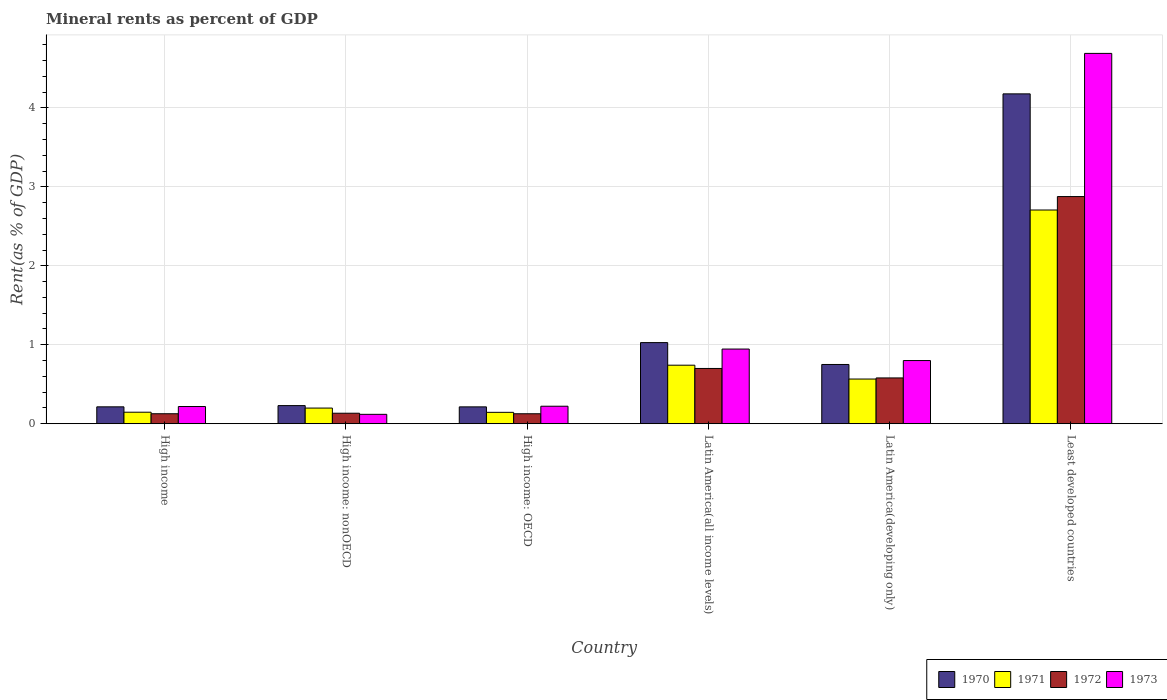How many groups of bars are there?
Your answer should be compact. 6. How many bars are there on the 2nd tick from the left?
Provide a short and direct response. 4. How many bars are there on the 2nd tick from the right?
Provide a succinct answer. 4. What is the label of the 5th group of bars from the left?
Offer a terse response. Latin America(developing only). In how many cases, is the number of bars for a given country not equal to the number of legend labels?
Your response must be concise. 0. What is the mineral rent in 1970 in High income: OECD?
Ensure brevity in your answer.  0.21. Across all countries, what is the maximum mineral rent in 1971?
Your answer should be compact. 2.71. Across all countries, what is the minimum mineral rent in 1971?
Ensure brevity in your answer.  0.14. In which country was the mineral rent in 1971 maximum?
Provide a succinct answer. Least developed countries. In which country was the mineral rent in 1972 minimum?
Your response must be concise. High income: OECD. What is the total mineral rent in 1972 in the graph?
Keep it short and to the point. 4.54. What is the difference between the mineral rent in 1971 in High income: OECD and that in Least developed countries?
Ensure brevity in your answer.  -2.56. What is the difference between the mineral rent in 1971 in High income: nonOECD and the mineral rent in 1973 in Latin America(all income levels)?
Your answer should be compact. -0.75. What is the average mineral rent in 1970 per country?
Your answer should be compact. 1.1. What is the difference between the mineral rent of/in 1972 and mineral rent of/in 1971 in High income: OECD?
Your answer should be compact. -0.02. What is the ratio of the mineral rent in 1973 in High income: OECD to that in High income: nonOECD?
Make the answer very short. 1.86. Is the mineral rent in 1972 in High income: nonOECD less than that in Latin America(all income levels)?
Keep it short and to the point. Yes. What is the difference between the highest and the second highest mineral rent in 1970?
Keep it short and to the point. -0.28. What is the difference between the highest and the lowest mineral rent in 1973?
Give a very brief answer. 4.57. Is the sum of the mineral rent in 1972 in High income: nonOECD and Latin America(all income levels) greater than the maximum mineral rent in 1971 across all countries?
Offer a very short reply. No. Is it the case that in every country, the sum of the mineral rent in 1970 and mineral rent in 1973 is greater than the sum of mineral rent in 1972 and mineral rent in 1971?
Your response must be concise. No. What does the 1st bar from the left in High income represents?
Your answer should be very brief. 1970. What does the 3rd bar from the right in Least developed countries represents?
Make the answer very short. 1971. How many bars are there?
Make the answer very short. 24. Does the graph contain any zero values?
Provide a succinct answer. No. Does the graph contain grids?
Provide a succinct answer. Yes. How many legend labels are there?
Make the answer very short. 4. How are the legend labels stacked?
Provide a succinct answer. Horizontal. What is the title of the graph?
Provide a succinct answer. Mineral rents as percent of GDP. What is the label or title of the Y-axis?
Keep it short and to the point. Rent(as % of GDP). What is the Rent(as % of GDP) in 1970 in High income?
Provide a succinct answer. 0.21. What is the Rent(as % of GDP) in 1971 in High income?
Offer a terse response. 0.15. What is the Rent(as % of GDP) of 1972 in High income?
Your answer should be compact. 0.13. What is the Rent(as % of GDP) in 1973 in High income?
Ensure brevity in your answer.  0.22. What is the Rent(as % of GDP) in 1970 in High income: nonOECD?
Offer a terse response. 0.23. What is the Rent(as % of GDP) in 1971 in High income: nonOECD?
Give a very brief answer. 0.2. What is the Rent(as % of GDP) of 1972 in High income: nonOECD?
Ensure brevity in your answer.  0.13. What is the Rent(as % of GDP) in 1973 in High income: nonOECD?
Provide a succinct answer. 0.12. What is the Rent(as % of GDP) in 1970 in High income: OECD?
Offer a very short reply. 0.21. What is the Rent(as % of GDP) of 1971 in High income: OECD?
Offer a very short reply. 0.14. What is the Rent(as % of GDP) in 1972 in High income: OECD?
Make the answer very short. 0.13. What is the Rent(as % of GDP) in 1973 in High income: OECD?
Your answer should be compact. 0.22. What is the Rent(as % of GDP) in 1970 in Latin America(all income levels)?
Offer a very short reply. 1.03. What is the Rent(as % of GDP) of 1971 in Latin America(all income levels)?
Offer a very short reply. 0.74. What is the Rent(as % of GDP) in 1972 in Latin America(all income levels)?
Your answer should be very brief. 0.7. What is the Rent(as % of GDP) in 1973 in Latin America(all income levels)?
Ensure brevity in your answer.  0.95. What is the Rent(as % of GDP) in 1970 in Latin America(developing only)?
Offer a terse response. 0.75. What is the Rent(as % of GDP) in 1971 in Latin America(developing only)?
Keep it short and to the point. 0.57. What is the Rent(as % of GDP) in 1972 in Latin America(developing only)?
Provide a short and direct response. 0.58. What is the Rent(as % of GDP) in 1973 in Latin America(developing only)?
Give a very brief answer. 0.8. What is the Rent(as % of GDP) of 1970 in Least developed countries?
Your response must be concise. 4.18. What is the Rent(as % of GDP) in 1971 in Least developed countries?
Your response must be concise. 2.71. What is the Rent(as % of GDP) of 1972 in Least developed countries?
Provide a succinct answer. 2.88. What is the Rent(as % of GDP) of 1973 in Least developed countries?
Keep it short and to the point. 4.69. Across all countries, what is the maximum Rent(as % of GDP) in 1970?
Make the answer very short. 4.18. Across all countries, what is the maximum Rent(as % of GDP) of 1971?
Offer a terse response. 2.71. Across all countries, what is the maximum Rent(as % of GDP) in 1972?
Provide a short and direct response. 2.88. Across all countries, what is the maximum Rent(as % of GDP) of 1973?
Provide a short and direct response. 4.69. Across all countries, what is the minimum Rent(as % of GDP) of 1970?
Offer a very short reply. 0.21. Across all countries, what is the minimum Rent(as % of GDP) of 1971?
Your answer should be very brief. 0.14. Across all countries, what is the minimum Rent(as % of GDP) in 1972?
Your answer should be very brief. 0.13. Across all countries, what is the minimum Rent(as % of GDP) in 1973?
Offer a terse response. 0.12. What is the total Rent(as % of GDP) of 1970 in the graph?
Offer a very short reply. 6.61. What is the total Rent(as % of GDP) of 1971 in the graph?
Your response must be concise. 4.5. What is the total Rent(as % of GDP) of 1972 in the graph?
Keep it short and to the point. 4.54. What is the total Rent(as % of GDP) of 1973 in the graph?
Offer a terse response. 6.99. What is the difference between the Rent(as % of GDP) in 1970 in High income and that in High income: nonOECD?
Offer a terse response. -0.02. What is the difference between the Rent(as % of GDP) of 1971 in High income and that in High income: nonOECD?
Provide a short and direct response. -0.05. What is the difference between the Rent(as % of GDP) of 1972 in High income and that in High income: nonOECD?
Give a very brief answer. -0.01. What is the difference between the Rent(as % of GDP) of 1973 in High income and that in High income: nonOECD?
Give a very brief answer. 0.1. What is the difference between the Rent(as % of GDP) of 1970 in High income and that in High income: OECD?
Your response must be concise. 0. What is the difference between the Rent(as % of GDP) in 1971 in High income and that in High income: OECD?
Ensure brevity in your answer.  0. What is the difference between the Rent(as % of GDP) of 1972 in High income and that in High income: OECD?
Ensure brevity in your answer.  0. What is the difference between the Rent(as % of GDP) in 1973 in High income and that in High income: OECD?
Give a very brief answer. -0. What is the difference between the Rent(as % of GDP) of 1970 in High income and that in Latin America(all income levels)?
Make the answer very short. -0.81. What is the difference between the Rent(as % of GDP) of 1971 in High income and that in Latin America(all income levels)?
Your response must be concise. -0.6. What is the difference between the Rent(as % of GDP) of 1972 in High income and that in Latin America(all income levels)?
Provide a short and direct response. -0.57. What is the difference between the Rent(as % of GDP) of 1973 in High income and that in Latin America(all income levels)?
Your response must be concise. -0.73. What is the difference between the Rent(as % of GDP) in 1970 in High income and that in Latin America(developing only)?
Offer a terse response. -0.54. What is the difference between the Rent(as % of GDP) in 1971 in High income and that in Latin America(developing only)?
Offer a terse response. -0.42. What is the difference between the Rent(as % of GDP) in 1972 in High income and that in Latin America(developing only)?
Your answer should be compact. -0.45. What is the difference between the Rent(as % of GDP) in 1973 in High income and that in Latin America(developing only)?
Your answer should be very brief. -0.58. What is the difference between the Rent(as % of GDP) of 1970 in High income and that in Least developed countries?
Your answer should be very brief. -3.96. What is the difference between the Rent(as % of GDP) in 1971 in High income and that in Least developed countries?
Offer a terse response. -2.56. What is the difference between the Rent(as % of GDP) in 1972 in High income and that in Least developed countries?
Ensure brevity in your answer.  -2.75. What is the difference between the Rent(as % of GDP) in 1973 in High income and that in Least developed countries?
Provide a succinct answer. -4.47. What is the difference between the Rent(as % of GDP) in 1970 in High income: nonOECD and that in High income: OECD?
Give a very brief answer. 0.02. What is the difference between the Rent(as % of GDP) in 1971 in High income: nonOECD and that in High income: OECD?
Provide a succinct answer. 0.05. What is the difference between the Rent(as % of GDP) of 1972 in High income: nonOECD and that in High income: OECD?
Offer a very short reply. 0.01. What is the difference between the Rent(as % of GDP) in 1973 in High income: nonOECD and that in High income: OECD?
Provide a succinct answer. -0.1. What is the difference between the Rent(as % of GDP) of 1970 in High income: nonOECD and that in Latin America(all income levels)?
Ensure brevity in your answer.  -0.8. What is the difference between the Rent(as % of GDP) in 1971 in High income: nonOECD and that in Latin America(all income levels)?
Provide a succinct answer. -0.54. What is the difference between the Rent(as % of GDP) in 1972 in High income: nonOECD and that in Latin America(all income levels)?
Provide a short and direct response. -0.57. What is the difference between the Rent(as % of GDP) of 1973 in High income: nonOECD and that in Latin America(all income levels)?
Offer a very short reply. -0.83. What is the difference between the Rent(as % of GDP) of 1970 in High income: nonOECD and that in Latin America(developing only)?
Provide a succinct answer. -0.52. What is the difference between the Rent(as % of GDP) of 1971 in High income: nonOECD and that in Latin America(developing only)?
Keep it short and to the point. -0.37. What is the difference between the Rent(as % of GDP) of 1972 in High income: nonOECD and that in Latin America(developing only)?
Your answer should be very brief. -0.45. What is the difference between the Rent(as % of GDP) of 1973 in High income: nonOECD and that in Latin America(developing only)?
Your response must be concise. -0.68. What is the difference between the Rent(as % of GDP) in 1970 in High income: nonOECD and that in Least developed countries?
Your answer should be compact. -3.95. What is the difference between the Rent(as % of GDP) in 1971 in High income: nonOECD and that in Least developed countries?
Your answer should be compact. -2.51. What is the difference between the Rent(as % of GDP) of 1972 in High income: nonOECD and that in Least developed countries?
Keep it short and to the point. -2.74. What is the difference between the Rent(as % of GDP) in 1973 in High income: nonOECD and that in Least developed countries?
Provide a short and direct response. -4.57. What is the difference between the Rent(as % of GDP) in 1970 in High income: OECD and that in Latin America(all income levels)?
Provide a succinct answer. -0.81. What is the difference between the Rent(as % of GDP) in 1971 in High income: OECD and that in Latin America(all income levels)?
Offer a terse response. -0.6. What is the difference between the Rent(as % of GDP) in 1972 in High income: OECD and that in Latin America(all income levels)?
Your answer should be compact. -0.57. What is the difference between the Rent(as % of GDP) of 1973 in High income: OECD and that in Latin America(all income levels)?
Your answer should be compact. -0.72. What is the difference between the Rent(as % of GDP) of 1970 in High income: OECD and that in Latin America(developing only)?
Your response must be concise. -0.54. What is the difference between the Rent(as % of GDP) in 1971 in High income: OECD and that in Latin America(developing only)?
Make the answer very short. -0.42. What is the difference between the Rent(as % of GDP) in 1972 in High income: OECD and that in Latin America(developing only)?
Make the answer very short. -0.45. What is the difference between the Rent(as % of GDP) of 1973 in High income: OECD and that in Latin America(developing only)?
Provide a succinct answer. -0.58. What is the difference between the Rent(as % of GDP) in 1970 in High income: OECD and that in Least developed countries?
Give a very brief answer. -3.96. What is the difference between the Rent(as % of GDP) of 1971 in High income: OECD and that in Least developed countries?
Your answer should be compact. -2.56. What is the difference between the Rent(as % of GDP) in 1972 in High income: OECD and that in Least developed countries?
Your response must be concise. -2.75. What is the difference between the Rent(as % of GDP) of 1973 in High income: OECD and that in Least developed countries?
Offer a very short reply. -4.47. What is the difference between the Rent(as % of GDP) in 1970 in Latin America(all income levels) and that in Latin America(developing only)?
Provide a short and direct response. 0.28. What is the difference between the Rent(as % of GDP) of 1971 in Latin America(all income levels) and that in Latin America(developing only)?
Your response must be concise. 0.18. What is the difference between the Rent(as % of GDP) of 1972 in Latin America(all income levels) and that in Latin America(developing only)?
Your answer should be compact. 0.12. What is the difference between the Rent(as % of GDP) of 1973 in Latin America(all income levels) and that in Latin America(developing only)?
Give a very brief answer. 0.15. What is the difference between the Rent(as % of GDP) of 1970 in Latin America(all income levels) and that in Least developed countries?
Provide a short and direct response. -3.15. What is the difference between the Rent(as % of GDP) of 1971 in Latin America(all income levels) and that in Least developed countries?
Ensure brevity in your answer.  -1.97. What is the difference between the Rent(as % of GDP) in 1972 in Latin America(all income levels) and that in Least developed countries?
Ensure brevity in your answer.  -2.18. What is the difference between the Rent(as % of GDP) of 1973 in Latin America(all income levels) and that in Least developed countries?
Offer a very short reply. -3.74. What is the difference between the Rent(as % of GDP) of 1970 in Latin America(developing only) and that in Least developed countries?
Your answer should be compact. -3.43. What is the difference between the Rent(as % of GDP) in 1971 in Latin America(developing only) and that in Least developed countries?
Your response must be concise. -2.14. What is the difference between the Rent(as % of GDP) in 1972 in Latin America(developing only) and that in Least developed countries?
Your response must be concise. -2.3. What is the difference between the Rent(as % of GDP) of 1973 in Latin America(developing only) and that in Least developed countries?
Give a very brief answer. -3.89. What is the difference between the Rent(as % of GDP) in 1970 in High income and the Rent(as % of GDP) in 1971 in High income: nonOECD?
Keep it short and to the point. 0.02. What is the difference between the Rent(as % of GDP) in 1970 in High income and the Rent(as % of GDP) in 1972 in High income: nonOECD?
Offer a terse response. 0.08. What is the difference between the Rent(as % of GDP) in 1970 in High income and the Rent(as % of GDP) in 1973 in High income: nonOECD?
Provide a short and direct response. 0.1. What is the difference between the Rent(as % of GDP) of 1971 in High income and the Rent(as % of GDP) of 1972 in High income: nonOECD?
Ensure brevity in your answer.  0.01. What is the difference between the Rent(as % of GDP) of 1971 in High income and the Rent(as % of GDP) of 1973 in High income: nonOECD?
Offer a very short reply. 0.03. What is the difference between the Rent(as % of GDP) of 1972 in High income and the Rent(as % of GDP) of 1973 in High income: nonOECD?
Your answer should be very brief. 0.01. What is the difference between the Rent(as % of GDP) of 1970 in High income and the Rent(as % of GDP) of 1971 in High income: OECD?
Give a very brief answer. 0.07. What is the difference between the Rent(as % of GDP) of 1970 in High income and the Rent(as % of GDP) of 1972 in High income: OECD?
Offer a terse response. 0.09. What is the difference between the Rent(as % of GDP) of 1970 in High income and the Rent(as % of GDP) of 1973 in High income: OECD?
Offer a very short reply. -0.01. What is the difference between the Rent(as % of GDP) in 1971 in High income and the Rent(as % of GDP) in 1972 in High income: OECD?
Keep it short and to the point. 0.02. What is the difference between the Rent(as % of GDP) in 1971 in High income and the Rent(as % of GDP) in 1973 in High income: OECD?
Provide a short and direct response. -0.08. What is the difference between the Rent(as % of GDP) of 1972 in High income and the Rent(as % of GDP) of 1973 in High income: OECD?
Your response must be concise. -0.1. What is the difference between the Rent(as % of GDP) in 1970 in High income and the Rent(as % of GDP) in 1971 in Latin America(all income levels)?
Offer a very short reply. -0.53. What is the difference between the Rent(as % of GDP) in 1970 in High income and the Rent(as % of GDP) in 1972 in Latin America(all income levels)?
Your answer should be compact. -0.49. What is the difference between the Rent(as % of GDP) in 1970 in High income and the Rent(as % of GDP) in 1973 in Latin America(all income levels)?
Provide a succinct answer. -0.73. What is the difference between the Rent(as % of GDP) of 1971 in High income and the Rent(as % of GDP) of 1972 in Latin America(all income levels)?
Ensure brevity in your answer.  -0.55. What is the difference between the Rent(as % of GDP) of 1971 in High income and the Rent(as % of GDP) of 1973 in Latin America(all income levels)?
Keep it short and to the point. -0.8. What is the difference between the Rent(as % of GDP) of 1972 in High income and the Rent(as % of GDP) of 1973 in Latin America(all income levels)?
Provide a short and direct response. -0.82. What is the difference between the Rent(as % of GDP) in 1970 in High income and the Rent(as % of GDP) in 1971 in Latin America(developing only)?
Your response must be concise. -0.35. What is the difference between the Rent(as % of GDP) of 1970 in High income and the Rent(as % of GDP) of 1972 in Latin America(developing only)?
Your answer should be very brief. -0.37. What is the difference between the Rent(as % of GDP) of 1970 in High income and the Rent(as % of GDP) of 1973 in Latin America(developing only)?
Offer a very short reply. -0.59. What is the difference between the Rent(as % of GDP) of 1971 in High income and the Rent(as % of GDP) of 1972 in Latin America(developing only)?
Your answer should be compact. -0.43. What is the difference between the Rent(as % of GDP) of 1971 in High income and the Rent(as % of GDP) of 1973 in Latin America(developing only)?
Provide a short and direct response. -0.65. What is the difference between the Rent(as % of GDP) in 1972 in High income and the Rent(as % of GDP) in 1973 in Latin America(developing only)?
Offer a terse response. -0.67. What is the difference between the Rent(as % of GDP) in 1970 in High income and the Rent(as % of GDP) in 1971 in Least developed countries?
Provide a short and direct response. -2.49. What is the difference between the Rent(as % of GDP) in 1970 in High income and the Rent(as % of GDP) in 1972 in Least developed countries?
Offer a very short reply. -2.66. What is the difference between the Rent(as % of GDP) in 1970 in High income and the Rent(as % of GDP) in 1973 in Least developed countries?
Ensure brevity in your answer.  -4.48. What is the difference between the Rent(as % of GDP) of 1971 in High income and the Rent(as % of GDP) of 1972 in Least developed countries?
Your response must be concise. -2.73. What is the difference between the Rent(as % of GDP) in 1971 in High income and the Rent(as % of GDP) in 1973 in Least developed countries?
Keep it short and to the point. -4.54. What is the difference between the Rent(as % of GDP) of 1972 in High income and the Rent(as % of GDP) of 1973 in Least developed countries?
Offer a terse response. -4.56. What is the difference between the Rent(as % of GDP) in 1970 in High income: nonOECD and the Rent(as % of GDP) in 1971 in High income: OECD?
Give a very brief answer. 0.09. What is the difference between the Rent(as % of GDP) of 1970 in High income: nonOECD and the Rent(as % of GDP) of 1972 in High income: OECD?
Offer a very short reply. 0.1. What is the difference between the Rent(as % of GDP) of 1970 in High income: nonOECD and the Rent(as % of GDP) of 1973 in High income: OECD?
Your answer should be compact. 0.01. What is the difference between the Rent(as % of GDP) of 1971 in High income: nonOECD and the Rent(as % of GDP) of 1972 in High income: OECD?
Provide a succinct answer. 0.07. What is the difference between the Rent(as % of GDP) of 1971 in High income: nonOECD and the Rent(as % of GDP) of 1973 in High income: OECD?
Provide a short and direct response. -0.02. What is the difference between the Rent(as % of GDP) in 1972 in High income: nonOECD and the Rent(as % of GDP) in 1973 in High income: OECD?
Ensure brevity in your answer.  -0.09. What is the difference between the Rent(as % of GDP) in 1970 in High income: nonOECD and the Rent(as % of GDP) in 1971 in Latin America(all income levels)?
Your answer should be very brief. -0.51. What is the difference between the Rent(as % of GDP) of 1970 in High income: nonOECD and the Rent(as % of GDP) of 1972 in Latin America(all income levels)?
Give a very brief answer. -0.47. What is the difference between the Rent(as % of GDP) of 1970 in High income: nonOECD and the Rent(as % of GDP) of 1973 in Latin America(all income levels)?
Your answer should be compact. -0.72. What is the difference between the Rent(as % of GDP) in 1971 in High income: nonOECD and the Rent(as % of GDP) in 1972 in Latin America(all income levels)?
Offer a terse response. -0.5. What is the difference between the Rent(as % of GDP) of 1971 in High income: nonOECD and the Rent(as % of GDP) of 1973 in Latin America(all income levels)?
Offer a very short reply. -0.75. What is the difference between the Rent(as % of GDP) of 1972 in High income: nonOECD and the Rent(as % of GDP) of 1973 in Latin America(all income levels)?
Make the answer very short. -0.81. What is the difference between the Rent(as % of GDP) of 1970 in High income: nonOECD and the Rent(as % of GDP) of 1971 in Latin America(developing only)?
Make the answer very short. -0.34. What is the difference between the Rent(as % of GDP) in 1970 in High income: nonOECD and the Rent(as % of GDP) in 1972 in Latin America(developing only)?
Ensure brevity in your answer.  -0.35. What is the difference between the Rent(as % of GDP) of 1970 in High income: nonOECD and the Rent(as % of GDP) of 1973 in Latin America(developing only)?
Offer a very short reply. -0.57. What is the difference between the Rent(as % of GDP) of 1971 in High income: nonOECD and the Rent(as % of GDP) of 1972 in Latin America(developing only)?
Give a very brief answer. -0.38. What is the difference between the Rent(as % of GDP) of 1971 in High income: nonOECD and the Rent(as % of GDP) of 1973 in Latin America(developing only)?
Your response must be concise. -0.6. What is the difference between the Rent(as % of GDP) of 1972 in High income: nonOECD and the Rent(as % of GDP) of 1973 in Latin America(developing only)?
Offer a very short reply. -0.67. What is the difference between the Rent(as % of GDP) in 1970 in High income: nonOECD and the Rent(as % of GDP) in 1971 in Least developed countries?
Your answer should be very brief. -2.48. What is the difference between the Rent(as % of GDP) in 1970 in High income: nonOECD and the Rent(as % of GDP) in 1972 in Least developed countries?
Your answer should be compact. -2.65. What is the difference between the Rent(as % of GDP) of 1970 in High income: nonOECD and the Rent(as % of GDP) of 1973 in Least developed countries?
Your response must be concise. -4.46. What is the difference between the Rent(as % of GDP) of 1971 in High income: nonOECD and the Rent(as % of GDP) of 1972 in Least developed countries?
Keep it short and to the point. -2.68. What is the difference between the Rent(as % of GDP) in 1971 in High income: nonOECD and the Rent(as % of GDP) in 1973 in Least developed countries?
Offer a very short reply. -4.49. What is the difference between the Rent(as % of GDP) of 1972 in High income: nonOECD and the Rent(as % of GDP) of 1973 in Least developed countries?
Your answer should be compact. -4.56. What is the difference between the Rent(as % of GDP) of 1970 in High income: OECD and the Rent(as % of GDP) of 1971 in Latin America(all income levels)?
Offer a very short reply. -0.53. What is the difference between the Rent(as % of GDP) in 1970 in High income: OECD and the Rent(as % of GDP) in 1972 in Latin America(all income levels)?
Provide a short and direct response. -0.49. What is the difference between the Rent(as % of GDP) of 1970 in High income: OECD and the Rent(as % of GDP) of 1973 in Latin America(all income levels)?
Your answer should be very brief. -0.73. What is the difference between the Rent(as % of GDP) in 1971 in High income: OECD and the Rent(as % of GDP) in 1972 in Latin America(all income levels)?
Your answer should be compact. -0.56. What is the difference between the Rent(as % of GDP) of 1971 in High income: OECD and the Rent(as % of GDP) of 1973 in Latin America(all income levels)?
Ensure brevity in your answer.  -0.8. What is the difference between the Rent(as % of GDP) of 1972 in High income: OECD and the Rent(as % of GDP) of 1973 in Latin America(all income levels)?
Your answer should be very brief. -0.82. What is the difference between the Rent(as % of GDP) in 1970 in High income: OECD and the Rent(as % of GDP) in 1971 in Latin America(developing only)?
Ensure brevity in your answer.  -0.35. What is the difference between the Rent(as % of GDP) of 1970 in High income: OECD and the Rent(as % of GDP) of 1972 in Latin America(developing only)?
Keep it short and to the point. -0.37. What is the difference between the Rent(as % of GDP) in 1970 in High income: OECD and the Rent(as % of GDP) in 1973 in Latin America(developing only)?
Your answer should be very brief. -0.59. What is the difference between the Rent(as % of GDP) of 1971 in High income: OECD and the Rent(as % of GDP) of 1972 in Latin America(developing only)?
Your answer should be very brief. -0.44. What is the difference between the Rent(as % of GDP) of 1971 in High income: OECD and the Rent(as % of GDP) of 1973 in Latin America(developing only)?
Your answer should be compact. -0.66. What is the difference between the Rent(as % of GDP) of 1972 in High income: OECD and the Rent(as % of GDP) of 1973 in Latin America(developing only)?
Give a very brief answer. -0.67. What is the difference between the Rent(as % of GDP) in 1970 in High income: OECD and the Rent(as % of GDP) in 1971 in Least developed countries?
Offer a very short reply. -2.49. What is the difference between the Rent(as % of GDP) in 1970 in High income: OECD and the Rent(as % of GDP) in 1972 in Least developed countries?
Offer a terse response. -2.66. What is the difference between the Rent(as % of GDP) of 1970 in High income: OECD and the Rent(as % of GDP) of 1973 in Least developed countries?
Provide a succinct answer. -4.48. What is the difference between the Rent(as % of GDP) of 1971 in High income: OECD and the Rent(as % of GDP) of 1972 in Least developed countries?
Give a very brief answer. -2.73. What is the difference between the Rent(as % of GDP) in 1971 in High income: OECD and the Rent(as % of GDP) in 1973 in Least developed countries?
Give a very brief answer. -4.55. What is the difference between the Rent(as % of GDP) of 1972 in High income: OECD and the Rent(as % of GDP) of 1973 in Least developed countries?
Provide a short and direct response. -4.56. What is the difference between the Rent(as % of GDP) of 1970 in Latin America(all income levels) and the Rent(as % of GDP) of 1971 in Latin America(developing only)?
Your response must be concise. 0.46. What is the difference between the Rent(as % of GDP) in 1970 in Latin America(all income levels) and the Rent(as % of GDP) in 1972 in Latin America(developing only)?
Keep it short and to the point. 0.45. What is the difference between the Rent(as % of GDP) of 1970 in Latin America(all income levels) and the Rent(as % of GDP) of 1973 in Latin America(developing only)?
Ensure brevity in your answer.  0.23. What is the difference between the Rent(as % of GDP) of 1971 in Latin America(all income levels) and the Rent(as % of GDP) of 1972 in Latin America(developing only)?
Your response must be concise. 0.16. What is the difference between the Rent(as % of GDP) of 1971 in Latin America(all income levels) and the Rent(as % of GDP) of 1973 in Latin America(developing only)?
Provide a succinct answer. -0.06. What is the difference between the Rent(as % of GDP) in 1972 in Latin America(all income levels) and the Rent(as % of GDP) in 1973 in Latin America(developing only)?
Make the answer very short. -0.1. What is the difference between the Rent(as % of GDP) in 1970 in Latin America(all income levels) and the Rent(as % of GDP) in 1971 in Least developed countries?
Give a very brief answer. -1.68. What is the difference between the Rent(as % of GDP) in 1970 in Latin America(all income levels) and the Rent(as % of GDP) in 1972 in Least developed countries?
Offer a very short reply. -1.85. What is the difference between the Rent(as % of GDP) of 1970 in Latin America(all income levels) and the Rent(as % of GDP) of 1973 in Least developed countries?
Make the answer very short. -3.66. What is the difference between the Rent(as % of GDP) of 1971 in Latin America(all income levels) and the Rent(as % of GDP) of 1972 in Least developed countries?
Keep it short and to the point. -2.14. What is the difference between the Rent(as % of GDP) in 1971 in Latin America(all income levels) and the Rent(as % of GDP) in 1973 in Least developed countries?
Give a very brief answer. -3.95. What is the difference between the Rent(as % of GDP) of 1972 in Latin America(all income levels) and the Rent(as % of GDP) of 1973 in Least developed countries?
Provide a short and direct response. -3.99. What is the difference between the Rent(as % of GDP) in 1970 in Latin America(developing only) and the Rent(as % of GDP) in 1971 in Least developed countries?
Keep it short and to the point. -1.96. What is the difference between the Rent(as % of GDP) of 1970 in Latin America(developing only) and the Rent(as % of GDP) of 1972 in Least developed countries?
Offer a very short reply. -2.13. What is the difference between the Rent(as % of GDP) in 1970 in Latin America(developing only) and the Rent(as % of GDP) in 1973 in Least developed countries?
Offer a terse response. -3.94. What is the difference between the Rent(as % of GDP) of 1971 in Latin America(developing only) and the Rent(as % of GDP) of 1972 in Least developed countries?
Offer a very short reply. -2.31. What is the difference between the Rent(as % of GDP) of 1971 in Latin America(developing only) and the Rent(as % of GDP) of 1973 in Least developed countries?
Provide a succinct answer. -4.12. What is the difference between the Rent(as % of GDP) of 1972 in Latin America(developing only) and the Rent(as % of GDP) of 1973 in Least developed countries?
Offer a very short reply. -4.11. What is the average Rent(as % of GDP) in 1970 per country?
Make the answer very short. 1.1. What is the average Rent(as % of GDP) in 1971 per country?
Ensure brevity in your answer.  0.75. What is the average Rent(as % of GDP) in 1972 per country?
Ensure brevity in your answer.  0.76. What is the average Rent(as % of GDP) in 1973 per country?
Offer a terse response. 1.17. What is the difference between the Rent(as % of GDP) in 1970 and Rent(as % of GDP) in 1971 in High income?
Offer a terse response. 0.07. What is the difference between the Rent(as % of GDP) in 1970 and Rent(as % of GDP) in 1972 in High income?
Your response must be concise. 0.09. What is the difference between the Rent(as % of GDP) in 1970 and Rent(as % of GDP) in 1973 in High income?
Your answer should be very brief. -0. What is the difference between the Rent(as % of GDP) of 1971 and Rent(as % of GDP) of 1972 in High income?
Ensure brevity in your answer.  0.02. What is the difference between the Rent(as % of GDP) of 1971 and Rent(as % of GDP) of 1973 in High income?
Keep it short and to the point. -0.07. What is the difference between the Rent(as % of GDP) in 1972 and Rent(as % of GDP) in 1973 in High income?
Give a very brief answer. -0.09. What is the difference between the Rent(as % of GDP) of 1970 and Rent(as % of GDP) of 1971 in High income: nonOECD?
Provide a succinct answer. 0.03. What is the difference between the Rent(as % of GDP) of 1970 and Rent(as % of GDP) of 1972 in High income: nonOECD?
Your answer should be very brief. 0.1. What is the difference between the Rent(as % of GDP) of 1970 and Rent(as % of GDP) of 1973 in High income: nonOECD?
Provide a short and direct response. 0.11. What is the difference between the Rent(as % of GDP) of 1971 and Rent(as % of GDP) of 1972 in High income: nonOECD?
Offer a very short reply. 0.07. What is the difference between the Rent(as % of GDP) of 1971 and Rent(as % of GDP) of 1973 in High income: nonOECD?
Ensure brevity in your answer.  0.08. What is the difference between the Rent(as % of GDP) of 1972 and Rent(as % of GDP) of 1973 in High income: nonOECD?
Your answer should be very brief. 0.01. What is the difference between the Rent(as % of GDP) of 1970 and Rent(as % of GDP) of 1971 in High income: OECD?
Your response must be concise. 0.07. What is the difference between the Rent(as % of GDP) of 1970 and Rent(as % of GDP) of 1972 in High income: OECD?
Ensure brevity in your answer.  0.09. What is the difference between the Rent(as % of GDP) in 1970 and Rent(as % of GDP) in 1973 in High income: OECD?
Make the answer very short. -0.01. What is the difference between the Rent(as % of GDP) in 1971 and Rent(as % of GDP) in 1972 in High income: OECD?
Provide a succinct answer. 0.02. What is the difference between the Rent(as % of GDP) in 1971 and Rent(as % of GDP) in 1973 in High income: OECD?
Offer a terse response. -0.08. What is the difference between the Rent(as % of GDP) in 1972 and Rent(as % of GDP) in 1973 in High income: OECD?
Your answer should be compact. -0.1. What is the difference between the Rent(as % of GDP) of 1970 and Rent(as % of GDP) of 1971 in Latin America(all income levels)?
Give a very brief answer. 0.29. What is the difference between the Rent(as % of GDP) in 1970 and Rent(as % of GDP) in 1972 in Latin America(all income levels)?
Ensure brevity in your answer.  0.33. What is the difference between the Rent(as % of GDP) in 1970 and Rent(as % of GDP) in 1973 in Latin America(all income levels)?
Your answer should be compact. 0.08. What is the difference between the Rent(as % of GDP) of 1971 and Rent(as % of GDP) of 1972 in Latin America(all income levels)?
Your response must be concise. 0.04. What is the difference between the Rent(as % of GDP) in 1971 and Rent(as % of GDP) in 1973 in Latin America(all income levels)?
Your response must be concise. -0.2. What is the difference between the Rent(as % of GDP) in 1972 and Rent(as % of GDP) in 1973 in Latin America(all income levels)?
Give a very brief answer. -0.25. What is the difference between the Rent(as % of GDP) in 1970 and Rent(as % of GDP) in 1971 in Latin America(developing only)?
Give a very brief answer. 0.18. What is the difference between the Rent(as % of GDP) of 1970 and Rent(as % of GDP) of 1972 in Latin America(developing only)?
Provide a succinct answer. 0.17. What is the difference between the Rent(as % of GDP) in 1970 and Rent(as % of GDP) in 1973 in Latin America(developing only)?
Provide a short and direct response. -0.05. What is the difference between the Rent(as % of GDP) in 1971 and Rent(as % of GDP) in 1972 in Latin America(developing only)?
Provide a succinct answer. -0.01. What is the difference between the Rent(as % of GDP) in 1971 and Rent(as % of GDP) in 1973 in Latin America(developing only)?
Provide a succinct answer. -0.23. What is the difference between the Rent(as % of GDP) of 1972 and Rent(as % of GDP) of 1973 in Latin America(developing only)?
Provide a succinct answer. -0.22. What is the difference between the Rent(as % of GDP) of 1970 and Rent(as % of GDP) of 1971 in Least developed countries?
Keep it short and to the point. 1.47. What is the difference between the Rent(as % of GDP) in 1970 and Rent(as % of GDP) in 1972 in Least developed countries?
Provide a short and direct response. 1.3. What is the difference between the Rent(as % of GDP) of 1970 and Rent(as % of GDP) of 1973 in Least developed countries?
Your answer should be very brief. -0.51. What is the difference between the Rent(as % of GDP) in 1971 and Rent(as % of GDP) in 1972 in Least developed countries?
Ensure brevity in your answer.  -0.17. What is the difference between the Rent(as % of GDP) of 1971 and Rent(as % of GDP) of 1973 in Least developed countries?
Your response must be concise. -1.98. What is the difference between the Rent(as % of GDP) in 1972 and Rent(as % of GDP) in 1973 in Least developed countries?
Offer a very short reply. -1.81. What is the ratio of the Rent(as % of GDP) in 1970 in High income to that in High income: nonOECD?
Your response must be concise. 0.93. What is the ratio of the Rent(as % of GDP) in 1971 in High income to that in High income: nonOECD?
Give a very brief answer. 0.74. What is the ratio of the Rent(as % of GDP) of 1972 in High income to that in High income: nonOECD?
Make the answer very short. 0.95. What is the ratio of the Rent(as % of GDP) of 1973 in High income to that in High income: nonOECD?
Make the answer very short. 1.83. What is the ratio of the Rent(as % of GDP) of 1970 in High income to that in High income: OECD?
Provide a short and direct response. 1. What is the ratio of the Rent(as % of GDP) in 1971 in High income to that in High income: OECD?
Give a very brief answer. 1.01. What is the ratio of the Rent(as % of GDP) of 1972 in High income to that in High income: OECD?
Your response must be concise. 1. What is the ratio of the Rent(as % of GDP) of 1973 in High income to that in High income: OECD?
Provide a succinct answer. 0.98. What is the ratio of the Rent(as % of GDP) of 1970 in High income to that in Latin America(all income levels)?
Keep it short and to the point. 0.21. What is the ratio of the Rent(as % of GDP) of 1971 in High income to that in Latin America(all income levels)?
Ensure brevity in your answer.  0.2. What is the ratio of the Rent(as % of GDP) in 1972 in High income to that in Latin America(all income levels)?
Offer a very short reply. 0.18. What is the ratio of the Rent(as % of GDP) in 1973 in High income to that in Latin America(all income levels)?
Make the answer very short. 0.23. What is the ratio of the Rent(as % of GDP) in 1970 in High income to that in Latin America(developing only)?
Provide a succinct answer. 0.29. What is the ratio of the Rent(as % of GDP) of 1971 in High income to that in Latin America(developing only)?
Your answer should be compact. 0.26. What is the ratio of the Rent(as % of GDP) in 1972 in High income to that in Latin America(developing only)?
Provide a succinct answer. 0.22. What is the ratio of the Rent(as % of GDP) in 1973 in High income to that in Latin America(developing only)?
Your response must be concise. 0.27. What is the ratio of the Rent(as % of GDP) of 1970 in High income to that in Least developed countries?
Ensure brevity in your answer.  0.05. What is the ratio of the Rent(as % of GDP) in 1971 in High income to that in Least developed countries?
Make the answer very short. 0.05. What is the ratio of the Rent(as % of GDP) in 1972 in High income to that in Least developed countries?
Your answer should be compact. 0.04. What is the ratio of the Rent(as % of GDP) in 1973 in High income to that in Least developed countries?
Provide a short and direct response. 0.05. What is the ratio of the Rent(as % of GDP) of 1970 in High income: nonOECD to that in High income: OECD?
Provide a short and direct response. 1.08. What is the ratio of the Rent(as % of GDP) in 1971 in High income: nonOECD to that in High income: OECD?
Give a very brief answer. 1.38. What is the ratio of the Rent(as % of GDP) of 1972 in High income: nonOECD to that in High income: OECD?
Your response must be concise. 1.05. What is the ratio of the Rent(as % of GDP) of 1973 in High income: nonOECD to that in High income: OECD?
Ensure brevity in your answer.  0.54. What is the ratio of the Rent(as % of GDP) in 1970 in High income: nonOECD to that in Latin America(all income levels)?
Offer a very short reply. 0.22. What is the ratio of the Rent(as % of GDP) in 1971 in High income: nonOECD to that in Latin America(all income levels)?
Give a very brief answer. 0.27. What is the ratio of the Rent(as % of GDP) in 1972 in High income: nonOECD to that in Latin America(all income levels)?
Your answer should be compact. 0.19. What is the ratio of the Rent(as % of GDP) in 1973 in High income: nonOECD to that in Latin America(all income levels)?
Make the answer very short. 0.13. What is the ratio of the Rent(as % of GDP) of 1970 in High income: nonOECD to that in Latin America(developing only)?
Make the answer very short. 0.31. What is the ratio of the Rent(as % of GDP) in 1971 in High income: nonOECD to that in Latin America(developing only)?
Make the answer very short. 0.35. What is the ratio of the Rent(as % of GDP) of 1972 in High income: nonOECD to that in Latin America(developing only)?
Your response must be concise. 0.23. What is the ratio of the Rent(as % of GDP) of 1973 in High income: nonOECD to that in Latin America(developing only)?
Provide a succinct answer. 0.15. What is the ratio of the Rent(as % of GDP) of 1970 in High income: nonOECD to that in Least developed countries?
Provide a short and direct response. 0.06. What is the ratio of the Rent(as % of GDP) of 1971 in High income: nonOECD to that in Least developed countries?
Provide a short and direct response. 0.07. What is the ratio of the Rent(as % of GDP) in 1972 in High income: nonOECD to that in Least developed countries?
Your answer should be very brief. 0.05. What is the ratio of the Rent(as % of GDP) of 1973 in High income: nonOECD to that in Least developed countries?
Ensure brevity in your answer.  0.03. What is the ratio of the Rent(as % of GDP) in 1970 in High income: OECD to that in Latin America(all income levels)?
Keep it short and to the point. 0.21. What is the ratio of the Rent(as % of GDP) in 1971 in High income: OECD to that in Latin America(all income levels)?
Make the answer very short. 0.19. What is the ratio of the Rent(as % of GDP) in 1972 in High income: OECD to that in Latin America(all income levels)?
Give a very brief answer. 0.18. What is the ratio of the Rent(as % of GDP) in 1973 in High income: OECD to that in Latin America(all income levels)?
Keep it short and to the point. 0.23. What is the ratio of the Rent(as % of GDP) of 1970 in High income: OECD to that in Latin America(developing only)?
Ensure brevity in your answer.  0.28. What is the ratio of the Rent(as % of GDP) of 1971 in High income: OECD to that in Latin America(developing only)?
Your answer should be compact. 0.26. What is the ratio of the Rent(as % of GDP) of 1972 in High income: OECD to that in Latin America(developing only)?
Your response must be concise. 0.22. What is the ratio of the Rent(as % of GDP) of 1973 in High income: OECD to that in Latin America(developing only)?
Ensure brevity in your answer.  0.28. What is the ratio of the Rent(as % of GDP) in 1970 in High income: OECD to that in Least developed countries?
Ensure brevity in your answer.  0.05. What is the ratio of the Rent(as % of GDP) in 1971 in High income: OECD to that in Least developed countries?
Offer a very short reply. 0.05. What is the ratio of the Rent(as % of GDP) of 1972 in High income: OECD to that in Least developed countries?
Ensure brevity in your answer.  0.04. What is the ratio of the Rent(as % of GDP) in 1973 in High income: OECD to that in Least developed countries?
Your answer should be very brief. 0.05. What is the ratio of the Rent(as % of GDP) in 1970 in Latin America(all income levels) to that in Latin America(developing only)?
Your response must be concise. 1.37. What is the ratio of the Rent(as % of GDP) in 1971 in Latin America(all income levels) to that in Latin America(developing only)?
Give a very brief answer. 1.31. What is the ratio of the Rent(as % of GDP) of 1972 in Latin America(all income levels) to that in Latin America(developing only)?
Provide a succinct answer. 1.21. What is the ratio of the Rent(as % of GDP) in 1973 in Latin America(all income levels) to that in Latin America(developing only)?
Provide a short and direct response. 1.18. What is the ratio of the Rent(as % of GDP) in 1970 in Latin America(all income levels) to that in Least developed countries?
Your response must be concise. 0.25. What is the ratio of the Rent(as % of GDP) in 1971 in Latin America(all income levels) to that in Least developed countries?
Offer a very short reply. 0.27. What is the ratio of the Rent(as % of GDP) of 1972 in Latin America(all income levels) to that in Least developed countries?
Your answer should be very brief. 0.24. What is the ratio of the Rent(as % of GDP) in 1973 in Latin America(all income levels) to that in Least developed countries?
Your response must be concise. 0.2. What is the ratio of the Rent(as % of GDP) of 1970 in Latin America(developing only) to that in Least developed countries?
Offer a terse response. 0.18. What is the ratio of the Rent(as % of GDP) of 1971 in Latin America(developing only) to that in Least developed countries?
Provide a succinct answer. 0.21. What is the ratio of the Rent(as % of GDP) in 1972 in Latin America(developing only) to that in Least developed countries?
Offer a very short reply. 0.2. What is the ratio of the Rent(as % of GDP) of 1973 in Latin America(developing only) to that in Least developed countries?
Offer a very short reply. 0.17. What is the difference between the highest and the second highest Rent(as % of GDP) in 1970?
Your answer should be compact. 3.15. What is the difference between the highest and the second highest Rent(as % of GDP) in 1971?
Give a very brief answer. 1.97. What is the difference between the highest and the second highest Rent(as % of GDP) of 1972?
Make the answer very short. 2.18. What is the difference between the highest and the second highest Rent(as % of GDP) in 1973?
Make the answer very short. 3.74. What is the difference between the highest and the lowest Rent(as % of GDP) in 1970?
Make the answer very short. 3.96. What is the difference between the highest and the lowest Rent(as % of GDP) in 1971?
Your answer should be compact. 2.56. What is the difference between the highest and the lowest Rent(as % of GDP) in 1972?
Provide a succinct answer. 2.75. What is the difference between the highest and the lowest Rent(as % of GDP) of 1973?
Keep it short and to the point. 4.57. 